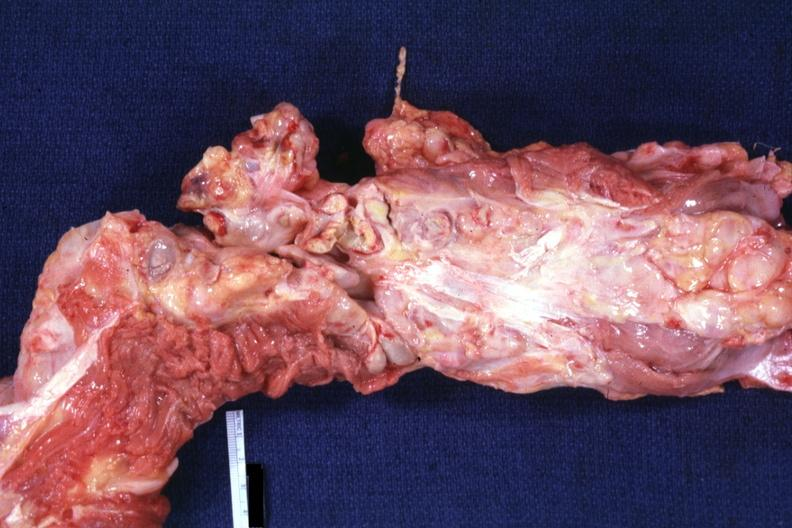what is aorta not opened?
Answer the question using a single word or phrase. Surrounded by large nodes 